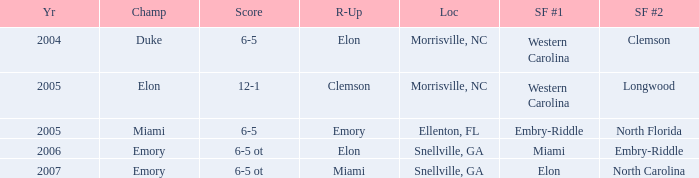List the scores of all games when Miami were listed as the first Semi finalist 6-5 ot. 